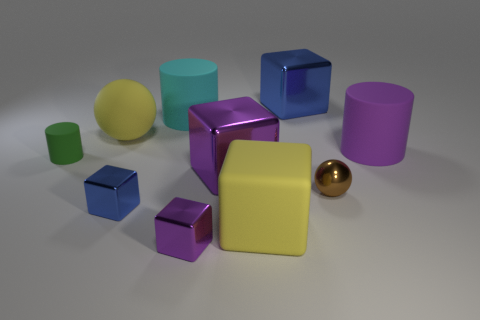Subtract all cyan balls. How many blue cubes are left? 2 Subtract all big blocks. How many blocks are left? 2 Subtract 1 cubes. How many cubes are left? 4 Subtract all yellow blocks. How many blocks are left? 4 Subtract all balls. How many objects are left? 8 Subtract all yellow blocks. Subtract all purple cylinders. How many blocks are left? 4 Add 1 purple cubes. How many purple cubes exist? 3 Subtract 0 red balls. How many objects are left? 10 Subtract all small blue cubes. Subtract all purple cylinders. How many objects are left? 8 Add 8 spheres. How many spheres are left? 10 